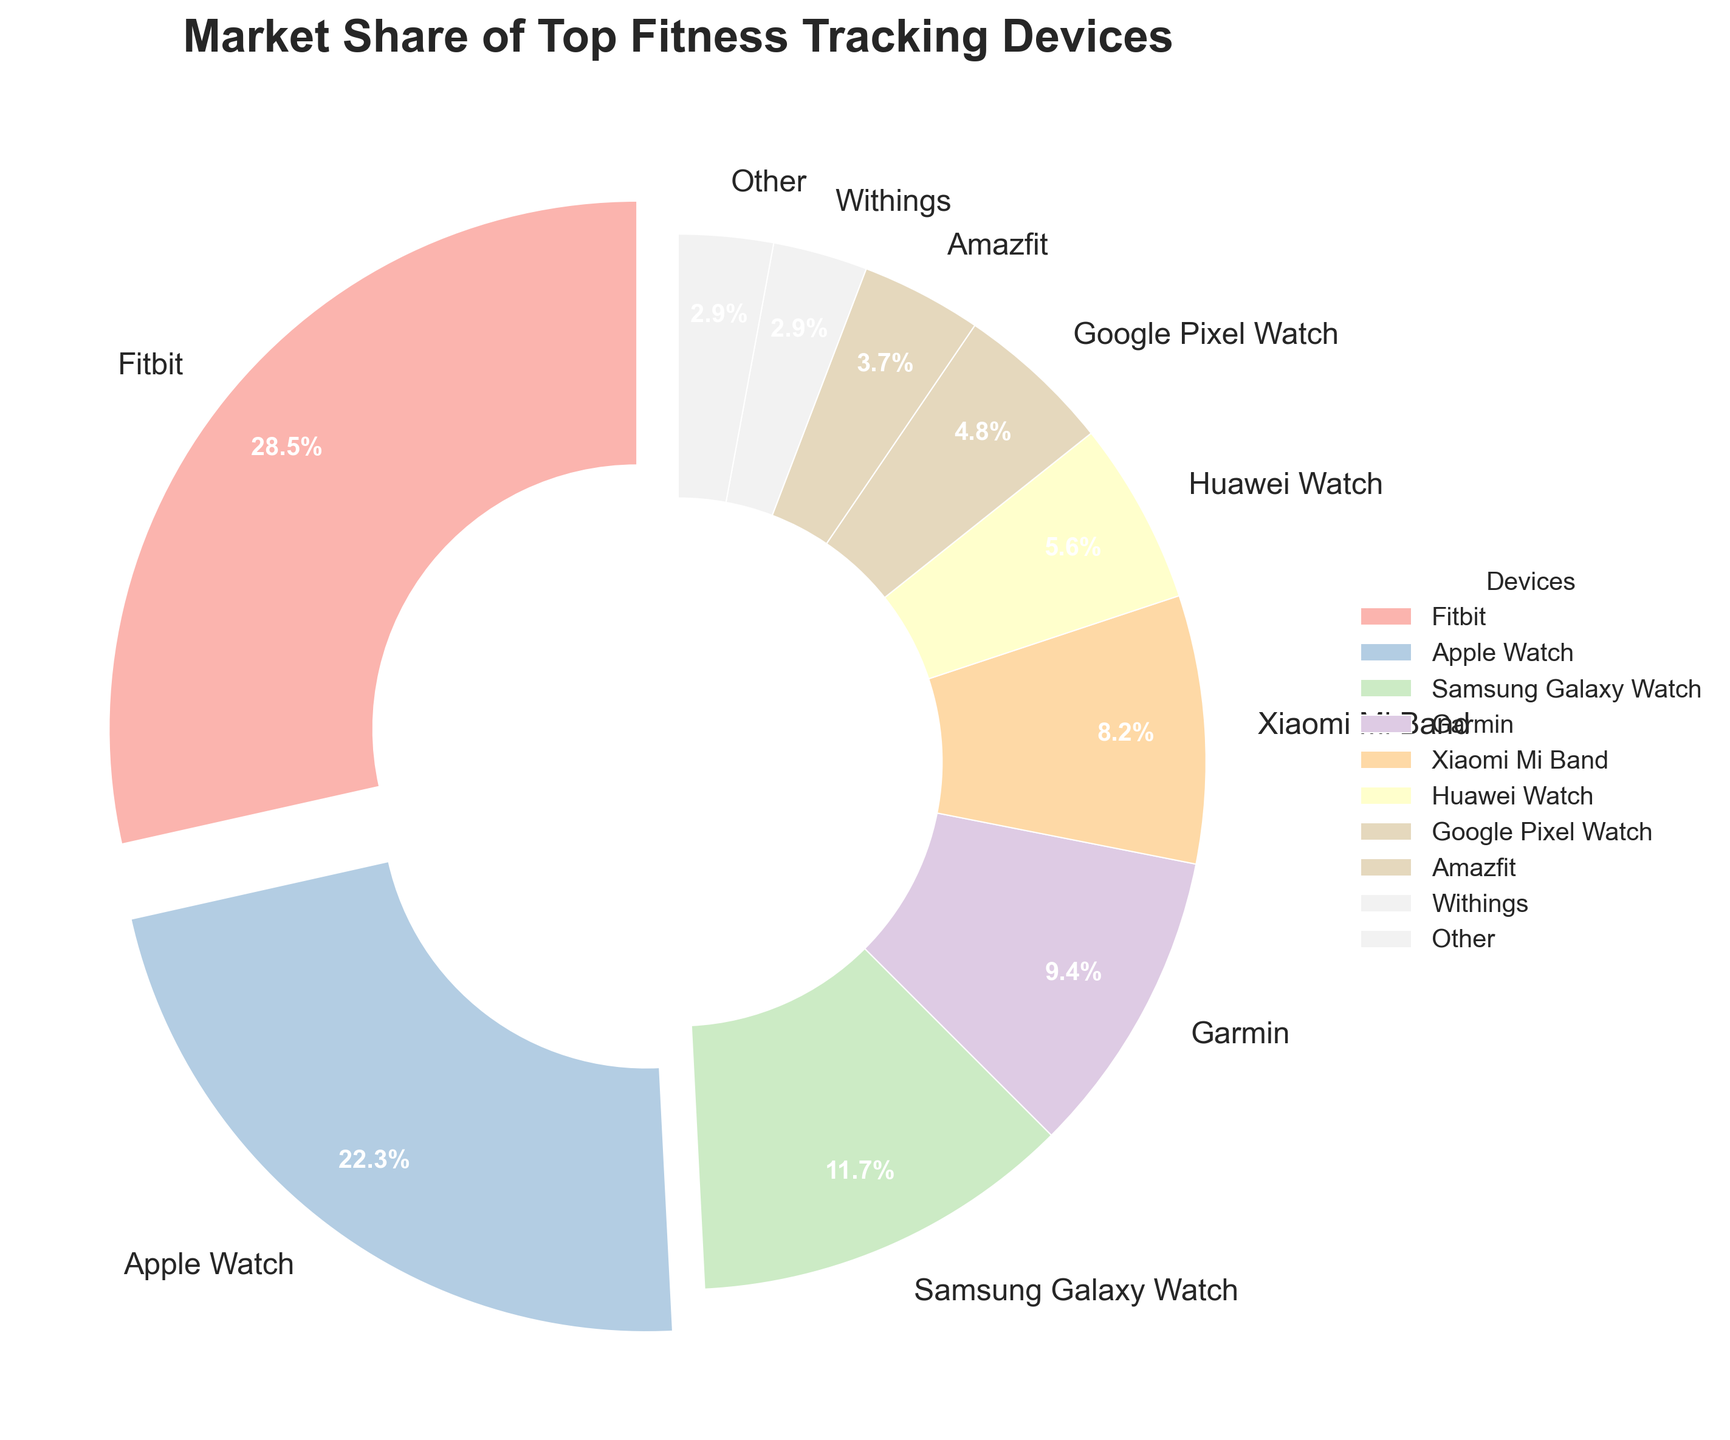What percentage of the market do the top 3 devices collectively hold? To find the collective market share of the top 3 devices, sum their individual market shares. Fitbit has 28.5%, Apple Watch has 22.3%, and Samsung Galaxy Watch has 11.7%. So, 28.5 + 22.3 + 11.7 = 62.5%.
Answer: 62.5 Which devices have a market share greater than 10%? By observing the pie chart, we can see that the devices with market shares greater than 10% are Fitbit, Apple Watch, and Samsung Galaxy Watch. Their respective shares are 28.5%, 22.3%, and 11.7%.
Answer: Fitbit, Apple Watch, Samsung Galaxy Watch How much more market share does Fitbit have compared to Garmin? To find out how much more market share Fitbit has than Garmin, we subtract Garmin's share from Fitbit's share. Fitbit has 28.5%, and Garmin has 9.4%. So, 28.5 - 9.4 = 19.1%.
Answer: 19.1 Do Xiaomi Mi Band and Huawei Watch collectively have a higher or lower market share compared to Apple Watch alone? First, find the collective market share of Xiaomi Mi Band and Huawei Watch: 8.2% + 5.6% = 13.8%. Apple Watch alone has a market share of 22.3%, which is higher than the combined share of the two devices.
Answer: Lower What are the market shares of devices with market shares less than 5%? By observing the chart, the devices with market shares less than 5% are: Google Pixel Watch 4.8%, Amazfit 3.7%, Withings 2.9%, and Other 2.9%.
Answer: Google Pixel Watch, Amazfit, Withings, Other Which device has the highest market share, and what is it? By observing the chart, the device with the highest market share is Fitbit, which has a market share of 28.5%.
Answer: Fitbit, 28.5 What is the average market share of all the devices shown? Sum the market shares of all devices: 28.5 + 22.3 + 11.7 + 9.4 + 8.2 + 5.6 + 4.8 + 3.7 + 2.9 + 2.9 = 100%. There are 10 devices. So, the average market share is 100/10 = 10%.
Answer: 10 If "Other" were to be split into five equal parts, what would be the market share of each part? "Other" has a market share of 2.9%. Splitting this into five equal parts, each part would have a share of 2.9% / 5 = 0.58%.
Answer: 0.58 